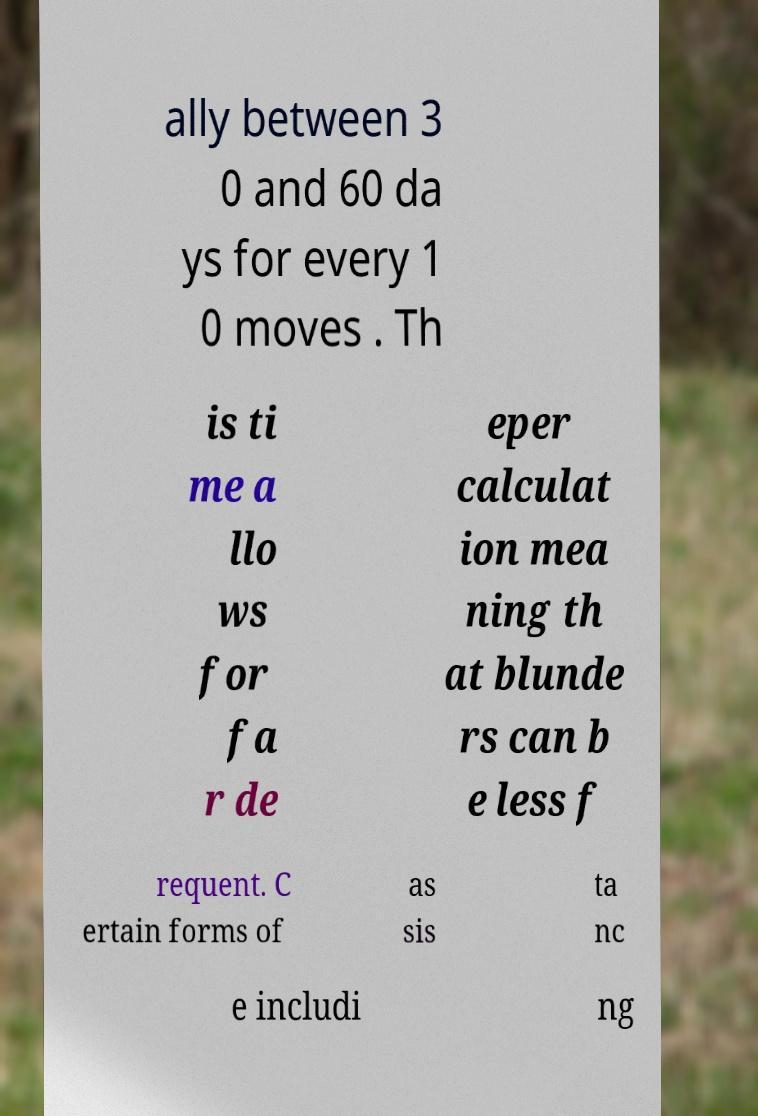Please identify and transcribe the text found in this image. ally between 3 0 and 60 da ys for every 1 0 moves . Th is ti me a llo ws for fa r de eper calculat ion mea ning th at blunde rs can b e less f requent. C ertain forms of as sis ta nc e includi ng 